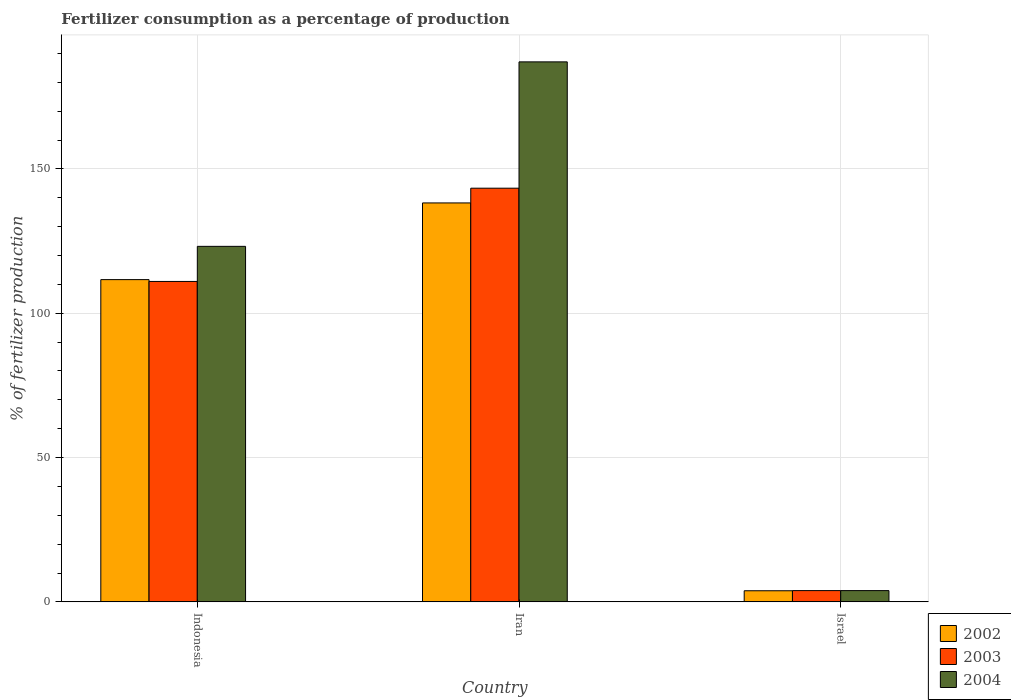How many groups of bars are there?
Offer a very short reply. 3. Are the number of bars per tick equal to the number of legend labels?
Make the answer very short. Yes. Are the number of bars on each tick of the X-axis equal?
Offer a very short reply. Yes. How many bars are there on the 1st tick from the right?
Your answer should be compact. 3. What is the label of the 2nd group of bars from the left?
Ensure brevity in your answer.  Iran. In how many cases, is the number of bars for a given country not equal to the number of legend labels?
Keep it short and to the point. 0. What is the percentage of fertilizers consumed in 2003 in Israel?
Your answer should be very brief. 3.9. Across all countries, what is the maximum percentage of fertilizers consumed in 2003?
Your answer should be very brief. 143.34. Across all countries, what is the minimum percentage of fertilizers consumed in 2003?
Provide a short and direct response. 3.9. In which country was the percentage of fertilizers consumed in 2004 maximum?
Keep it short and to the point. Iran. What is the total percentage of fertilizers consumed in 2003 in the graph?
Provide a short and direct response. 258.27. What is the difference between the percentage of fertilizers consumed in 2004 in Iran and that in Israel?
Provide a short and direct response. 183.2. What is the difference between the percentage of fertilizers consumed in 2004 in Israel and the percentage of fertilizers consumed in 2003 in Indonesia?
Provide a succinct answer. -107.12. What is the average percentage of fertilizers consumed in 2002 per country?
Offer a terse response. 84.58. What is the difference between the percentage of fertilizers consumed of/in 2002 and percentage of fertilizers consumed of/in 2003 in Indonesia?
Your response must be concise. 0.63. What is the ratio of the percentage of fertilizers consumed in 2004 in Indonesia to that in Israel?
Provide a short and direct response. 31.55. What is the difference between the highest and the second highest percentage of fertilizers consumed in 2003?
Offer a very short reply. -107.12. What is the difference between the highest and the lowest percentage of fertilizers consumed in 2004?
Your answer should be very brief. 183.2. In how many countries, is the percentage of fertilizers consumed in 2003 greater than the average percentage of fertilizers consumed in 2003 taken over all countries?
Your answer should be compact. 2. What does the 2nd bar from the left in Israel represents?
Give a very brief answer. 2003. What does the 3rd bar from the right in Iran represents?
Provide a succinct answer. 2002. Is it the case that in every country, the sum of the percentage of fertilizers consumed in 2003 and percentage of fertilizers consumed in 2004 is greater than the percentage of fertilizers consumed in 2002?
Give a very brief answer. Yes. Are all the bars in the graph horizontal?
Give a very brief answer. No. How many countries are there in the graph?
Your answer should be compact. 3. Does the graph contain any zero values?
Give a very brief answer. No. Does the graph contain grids?
Keep it short and to the point. Yes. How are the legend labels stacked?
Offer a terse response. Vertical. What is the title of the graph?
Offer a terse response. Fertilizer consumption as a percentage of production. Does "2008" appear as one of the legend labels in the graph?
Provide a short and direct response. No. What is the label or title of the Y-axis?
Your response must be concise. % of fertilizer production. What is the % of fertilizer production of 2002 in Indonesia?
Your response must be concise. 111.66. What is the % of fertilizer production in 2003 in Indonesia?
Provide a succinct answer. 111.02. What is the % of fertilizer production of 2004 in Indonesia?
Make the answer very short. 123.19. What is the % of fertilizer production in 2002 in Iran?
Provide a short and direct response. 138.23. What is the % of fertilizer production in 2003 in Iran?
Keep it short and to the point. 143.34. What is the % of fertilizer production of 2004 in Iran?
Keep it short and to the point. 187.1. What is the % of fertilizer production in 2002 in Israel?
Give a very brief answer. 3.85. What is the % of fertilizer production in 2003 in Israel?
Provide a short and direct response. 3.9. What is the % of fertilizer production of 2004 in Israel?
Your response must be concise. 3.9. Across all countries, what is the maximum % of fertilizer production in 2002?
Your answer should be compact. 138.23. Across all countries, what is the maximum % of fertilizer production in 2003?
Provide a short and direct response. 143.34. Across all countries, what is the maximum % of fertilizer production of 2004?
Ensure brevity in your answer.  187.1. Across all countries, what is the minimum % of fertilizer production of 2002?
Your answer should be compact. 3.85. Across all countries, what is the minimum % of fertilizer production of 2003?
Ensure brevity in your answer.  3.9. Across all countries, what is the minimum % of fertilizer production in 2004?
Offer a terse response. 3.9. What is the total % of fertilizer production in 2002 in the graph?
Offer a terse response. 253.74. What is the total % of fertilizer production of 2003 in the graph?
Ensure brevity in your answer.  258.27. What is the total % of fertilizer production of 2004 in the graph?
Provide a succinct answer. 314.19. What is the difference between the % of fertilizer production of 2002 in Indonesia and that in Iran?
Make the answer very short. -26.57. What is the difference between the % of fertilizer production of 2003 in Indonesia and that in Iran?
Give a very brief answer. -32.31. What is the difference between the % of fertilizer production in 2004 in Indonesia and that in Iran?
Offer a very short reply. -63.92. What is the difference between the % of fertilizer production of 2002 in Indonesia and that in Israel?
Offer a very short reply. 107.81. What is the difference between the % of fertilizer production in 2003 in Indonesia and that in Israel?
Your response must be concise. 107.12. What is the difference between the % of fertilizer production of 2004 in Indonesia and that in Israel?
Offer a terse response. 119.28. What is the difference between the % of fertilizer production in 2002 in Iran and that in Israel?
Keep it short and to the point. 134.38. What is the difference between the % of fertilizer production in 2003 in Iran and that in Israel?
Offer a terse response. 139.43. What is the difference between the % of fertilizer production in 2004 in Iran and that in Israel?
Your answer should be very brief. 183.2. What is the difference between the % of fertilizer production of 2002 in Indonesia and the % of fertilizer production of 2003 in Iran?
Your answer should be compact. -31.68. What is the difference between the % of fertilizer production in 2002 in Indonesia and the % of fertilizer production in 2004 in Iran?
Make the answer very short. -75.45. What is the difference between the % of fertilizer production of 2003 in Indonesia and the % of fertilizer production of 2004 in Iran?
Provide a succinct answer. -76.08. What is the difference between the % of fertilizer production in 2002 in Indonesia and the % of fertilizer production in 2003 in Israel?
Your response must be concise. 107.75. What is the difference between the % of fertilizer production of 2002 in Indonesia and the % of fertilizer production of 2004 in Israel?
Your answer should be very brief. 107.75. What is the difference between the % of fertilizer production of 2003 in Indonesia and the % of fertilizer production of 2004 in Israel?
Offer a terse response. 107.12. What is the difference between the % of fertilizer production in 2002 in Iran and the % of fertilizer production in 2003 in Israel?
Offer a very short reply. 134.32. What is the difference between the % of fertilizer production in 2002 in Iran and the % of fertilizer production in 2004 in Israel?
Provide a short and direct response. 134.32. What is the difference between the % of fertilizer production in 2003 in Iran and the % of fertilizer production in 2004 in Israel?
Give a very brief answer. 139.43. What is the average % of fertilizer production in 2002 per country?
Your answer should be compact. 84.58. What is the average % of fertilizer production in 2003 per country?
Provide a succinct answer. 86.09. What is the average % of fertilizer production in 2004 per country?
Offer a terse response. 104.73. What is the difference between the % of fertilizer production of 2002 and % of fertilizer production of 2003 in Indonesia?
Provide a short and direct response. 0.63. What is the difference between the % of fertilizer production in 2002 and % of fertilizer production in 2004 in Indonesia?
Your answer should be compact. -11.53. What is the difference between the % of fertilizer production in 2003 and % of fertilizer production in 2004 in Indonesia?
Make the answer very short. -12.16. What is the difference between the % of fertilizer production in 2002 and % of fertilizer production in 2003 in Iran?
Your answer should be compact. -5.11. What is the difference between the % of fertilizer production in 2002 and % of fertilizer production in 2004 in Iran?
Your response must be concise. -48.88. What is the difference between the % of fertilizer production in 2003 and % of fertilizer production in 2004 in Iran?
Offer a very short reply. -43.77. What is the difference between the % of fertilizer production of 2002 and % of fertilizer production of 2003 in Israel?
Give a very brief answer. -0.05. What is the difference between the % of fertilizer production of 2002 and % of fertilizer production of 2004 in Israel?
Keep it short and to the point. -0.05. What is the difference between the % of fertilizer production in 2003 and % of fertilizer production in 2004 in Israel?
Offer a very short reply. -0. What is the ratio of the % of fertilizer production in 2002 in Indonesia to that in Iran?
Your answer should be very brief. 0.81. What is the ratio of the % of fertilizer production of 2003 in Indonesia to that in Iran?
Provide a short and direct response. 0.77. What is the ratio of the % of fertilizer production in 2004 in Indonesia to that in Iran?
Provide a short and direct response. 0.66. What is the ratio of the % of fertilizer production of 2002 in Indonesia to that in Israel?
Your response must be concise. 28.98. What is the ratio of the % of fertilizer production in 2003 in Indonesia to that in Israel?
Keep it short and to the point. 28.44. What is the ratio of the % of fertilizer production of 2004 in Indonesia to that in Israel?
Keep it short and to the point. 31.55. What is the ratio of the % of fertilizer production of 2002 in Iran to that in Israel?
Your response must be concise. 35.88. What is the ratio of the % of fertilizer production of 2003 in Iran to that in Israel?
Your answer should be compact. 36.72. What is the ratio of the % of fertilizer production of 2004 in Iran to that in Israel?
Your answer should be very brief. 47.92. What is the difference between the highest and the second highest % of fertilizer production in 2002?
Keep it short and to the point. 26.57. What is the difference between the highest and the second highest % of fertilizer production in 2003?
Make the answer very short. 32.31. What is the difference between the highest and the second highest % of fertilizer production in 2004?
Your answer should be compact. 63.92. What is the difference between the highest and the lowest % of fertilizer production in 2002?
Your answer should be compact. 134.38. What is the difference between the highest and the lowest % of fertilizer production in 2003?
Your response must be concise. 139.43. What is the difference between the highest and the lowest % of fertilizer production of 2004?
Provide a succinct answer. 183.2. 